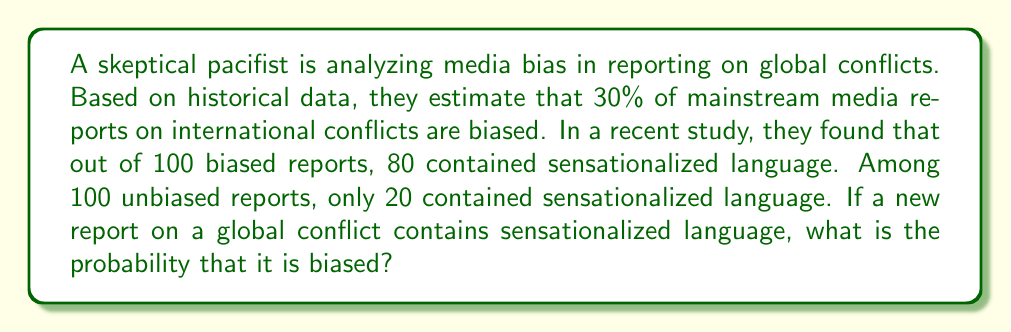Provide a solution to this math problem. Let's approach this problem using Bayesian inference:

1. Define our events:
   B: The report is biased
   S: The report contains sensationalized language

2. Given information:
   P(B) = 0.30 (prior probability of a report being biased)
   P(S|B) = 0.80 (probability of sensationalized language given the report is biased)
   P(S|not B) = 0.20 (probability of sensationalized language given the report is unbiased)

3. We want to find P(B|S) using Bayes' theorem:

   $$P(B|S) = \frac{P(S|B) \cdot P(B)}{P(S)}$$

4. Calculate P(S) using the law of total probability:
   
   $$P(S) = P(S|B) \cdot P(B) + P(S|not B) \cdot P(not B)$$
   $$P(S) = 0.80 \cdot 0.30 + 0.20 \cdot 0.70 = 0.24 + 0.14 = 0.38$$

5. Now we can apply Bayes' theorem:

   $$P(B|S) = \frac{0.80 \cdot 0.30}{0.38} = \frac{0.24}{0.38} \approx 0.6316$$

6. Convert to a percentage:
   0.6316 * 100% ≈ 63.16%

Therefore, if a new report on a global conflict contains sensationalized language, there is approximately a 63.16% chance that it is biased.
Answer: 63.16% 